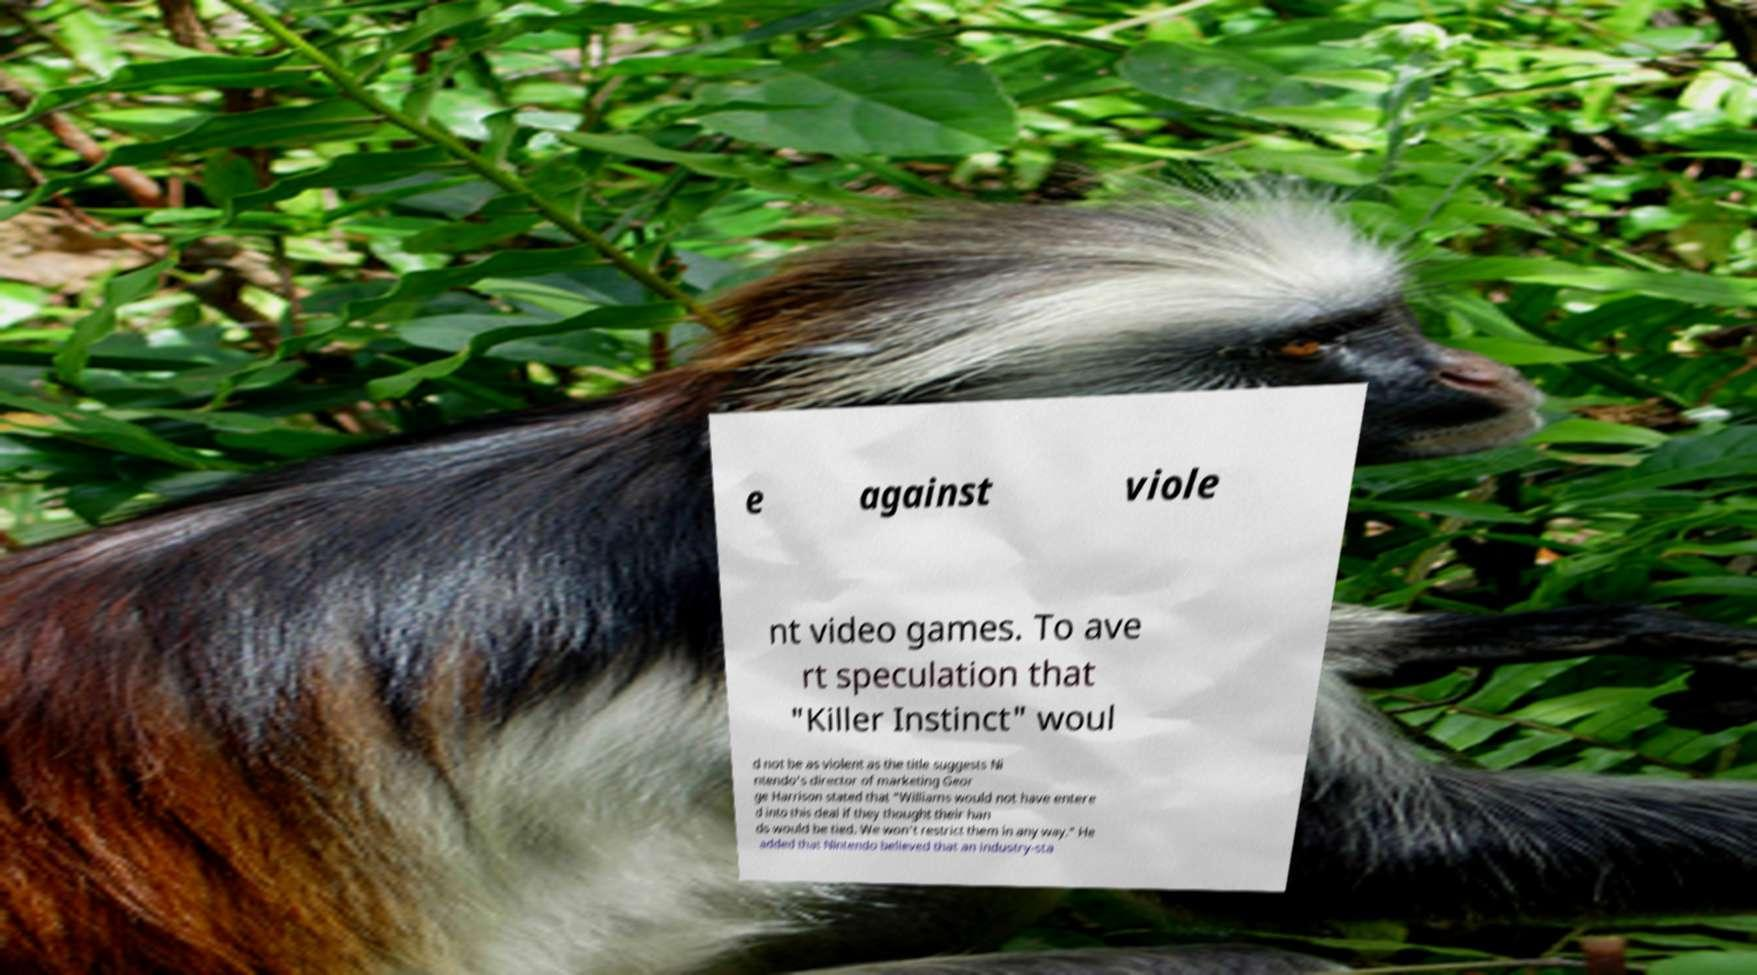Could you assist in decoding the text presented in this image and type it out clearly? e against viole nt video games. To ave rt speculation that "Killer Instinct" woul d not be as violent as the title suggests Ni ntendo's director of marketing Geor ge Harrison stated that "Williams would not have entere d into this deal if they thought their han ds would be tied. We won't restrict them in any way." He added that Nintendo believed that an industry-sta 